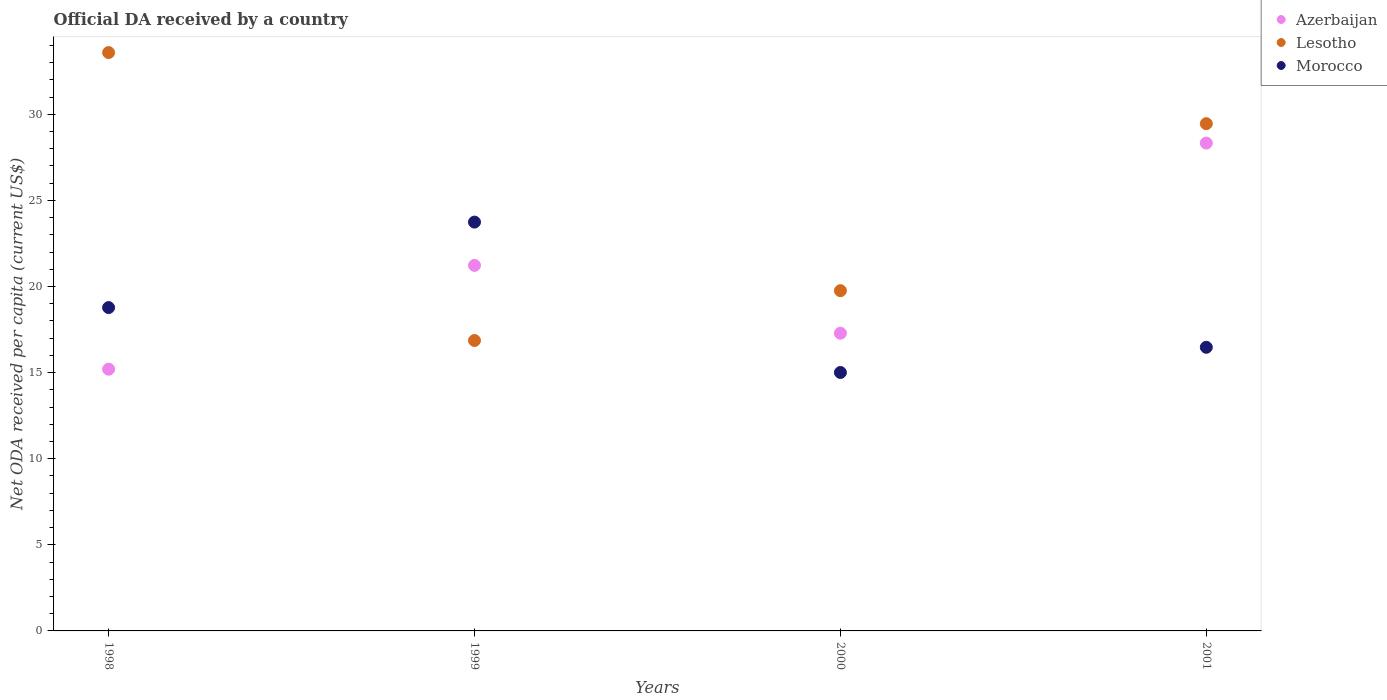How many different coloured dotlines are there?
Your answer should be very brief. 3. What is the ODA received in in Azerbaijan in 1999?
Provide a short and direct response. 21.22. Across all years, what is the maximum ODA received in in Morocco?
Give a very brief answer. 23.74. Across all years, what is the minimum ODA received in in Lesotho?
Make the answer very short. 16.86. In which year was the ODA received in in Azerbaijan maximum?
Offer a very short reply. 2001. What is the total ODA received in in Morocco in the graph?
Provide a succinct answer. 73.98. What is the difference between the ODA received in in Lesotho in 1999 and that in 2000?
Your answer should be compact. -2.89. What is the difference between the ODA received in in Azerbaijan in 1999 and the ODA received in in Lesotho in 2000?
Your answer should be very brief. 1.47. What is the average ODA received in in Azerbaijan per year?
Offer a very short reply. 20.51. In the year 1999, what is the difference between the ODA received in in Azerbaijan and ODA received in in Morocco?
Provide a succinct answer. -2.51. In how many years, is the ODA received in in Lesotho greater than 1 US$?
Ensure brevity in your answer.  4. What is the ratio of the ODA received in in Azerbaijan in 1999 to that in 2001?
Your answer should be compact. 0.75. Is the ODA received in in Morocco in 1998 less than that in 2001?
Offer a terse response. No. What is the difference between the highest and the second highest ODA received in in Morocco?
Your answer should be very brief. 4.96. What is the difference between the highest and the lowest ODA received in in Lesotho?
Make the answer very short. 16.72. In how many years, is the ODA received in in Morocco greater than the average ODA received in in Morocco taken over all years?
Offer a very short reply. 2. Is the ODA received in in Azerbaijan strictly greater than the ODA received in in Morocco over the years?
Ensure brevity in your answer.  No. How many dotlines are there?
Make the answer very short. 3. Does the graph contain any zero values?
Offer a terse response. No. What is the title of the graph?
Ensure brevity in your answer.  Official DA received by a country. What is the label or title of the X-axis?
Offer a very short reply. Years. What is the label or title of the Y-axis?
Offer a terse response. Net ODA received per capita (current US$). What is the Net ODA received per capita (current US$) of Azerbaijan in 1998?
Make the answer very short. 15.2. What is the Net ODA received per capita (current US$) in Lesotho in 1998?
Provide a succinct answer. 33.58. What is the Net ODA received per capita (current US$) of Morocco in 1998?
Your answer should be very brief. 18.77. What is the Net ODA received per capita (current US$) of Azerbaijan in 1999?
Keep it short and to the point. 21.22. What is the Net ODA received per capita (current US$) in Lesotho in 1999?
Ensure brevity in your answer.  16.86. What is the Net ODA received per capita (current US$) in Morocco in 1999?
Ensure brevity in your answer.  23.74. What is the Net ODA received per capita (current US$) of Azerbaijan in 2000?
Provide a succinct answer. 17.28. What is the Net ODA received per capita (current US$) in Lesotho in 2000?
Give a very brief answer. 19.76. What is the Net ODA received per capita (current US$) in Morocco in 2000?
Provide a short and direct response. 15.01. What is the Net ODA received per capita (current US$) of Azerbaijan in 2001?
Give a very brief answer. 28.33. What is the Net ODA received per capita (current US$) in Lesotho in 2001?
Offer a terse response. 29.45. What is the Net ODA received per capita (current US$) in Morocco in 2001?
Your answer should be very brief. 16.47. Across all years, what is the maximum Net ODA received per capita (current US$) of Azerbaijan?
Offer a very short reply. 28.33. Across all years, what is the maximum Net ODA received per capita (current US$) of Lesotho?
Your response must be concise. 33.58. Across all years, what is the maximum Net ODA received per capita (current US$) in Morocco?
Your answer should be compact. 23.74. Across all years, what is the minimum Net ODA received per capita (current US$) of Azerbaijan?
Make the answer very short. 15.2. Across all years, what is the minimum Net ODA received per capita (current US$) in Lesotho?
Provide a succinct answer. 16.86. Across all years, what is the minimum Net ODA received per capita (current US$) of Morocco?
Ensure brevity in your answer.  15.01. What is the total Net ODA received per capita (current US$) of Azerbaijan in the graph?
Offer a very short reply. 82.03. What is the total Net ODA received per capita (current US$) of Lesotho in the graph?
Give a very brief answer. 99.65. What is the total Net ODA received per capita (current US$) in Morocco in the graph?
Make the answer very short. 73.98. What is the difference between the Net ODA received per capita (current US$) of Azerbaijan in 1998 and that in 1999?
Keep it short and to the point. -6.03. What is the difference between the Net ODA received per capita (current US$) in Lesotho in 1998 and that in 1999?
Make the answer very short. 16.72. What is the difference between the Net ODA received per capita (current US$) of Morocco in 1998 and that in 1999?
Make the answer very short. -4.96. What is the difference between the Net ODA received per capita (current US$) of Azerbaijan in 1998 and that in 2000?
Ensure brevity in your answer.  -2.09. What is the difference between the Net ODA received per capita (current US$) of Lesotho in 1998 and that in 2000?
Make the answer very short. 13.82. What is the difference between the Net ODA received per capita (current US$) in Morocco in 1998 and that in 2000?
Your answer should be very brief. 3.77. What is the difference between the Net ODA received per capita (current US$) in Azerbaijan in 1998 and that in 2001?
Keep it short and to the point. -13.13. What is the difference between the Net ODA received per capita (current US$) in Lesotho in 1998 and that in 2001?
Your response must be concise. 4.13. What is the difference between the Net ODA received per capita (current US$) in Morocco in 1998 and that in 2001?
Ensure brevity in your answer.  2.31. What is the difference between the Net ODA received per capita (current US$) in Azerbaijan in 1999 and that in 2000?
Give a very brief answer. 3.94. What is the difference between the Net ODA received per capita (current US$) in Lesotho in 1999 and that in 2000?
Your answer should be very brief. -2.89. What is the difference between the Net ODA received per capita (current US$) of Morocco in 1999 and that in 2000?
Offer a terse response. 8.73. What is the difference between the Net ODA received per capita (current US$) in Azerbaijan in 1999 and that in 2001?
Provide a short and direct response. -7.1. What is the difference between the Net ODA received per capita (current US$) of Lesotho in 1999 and that in 2001?
Make the answer very short. -12.59. What is the difference between the Net ODA received per capita (current US$) of Morocco in 1999 and that in 2001?
Your answer should be very brief. 7.27. What is the difference between the Net ODA received per capita (current US$) in Azerbaijan in 2000 and that in 2001?
Your answer should be very brief. -11.04. What is the difference between the Net ODA received per capita (current US$) in Lesotho in 2000 and that in 2001?
Your answer should be compact. -9.7. What is the difference between the Net ODA received per capita (current US$) of Morocco in 2000 and that in 2001?
Make the answer very short. -1.46. What is the difference between the Net ODA received per capita (current US$) of Azerbaijan in 1998 and the Net ODA received per capita (current US$) of Lesotho in 1999?
Make the answer very short. -1.67. What is the difference between the Net ODA received per capita (current US$) in Azerbaijan in 1998 and the Net ODA received per capita (current US$) in Morocco in 1999?
Ensure brevity in your answer.  -8.54. What is the difference between the Net ODA received per capita (current US$) of Lesotho in 1998 and the Net ODA received per capita (current US$) of Morocco in 1999?
Offer a terse response. 9.84. What is the difference between the Net ODA received per capita (current US$) in Azerbaijan in 1998 and the Net ODA received per capita (current US$) in Lesotho in 2000?
Keep it short and to the point. -4.56. What is the difference between the Net ODA received per capita (current US$) in Azerbaijan in 1998 and the Net ODA received per capita (current US$) in Morocco in 2000?
Provide a short and direct response. 0.19. What is the difference between the Net ODA received per capita (current US$) in Lesotho in 1998 and the Net ODA received per capita (current US$) in Morocco in 2000?
Your answer should be very brief. 18.57. What is the difference between the Net ODA received per capita (current US$) in Azerbaijan in 1998 and the Net ODA received per capita (current US$) in Lesotho in 2001?
Make the answer very short. -14.26. What is the difference between the Net ODA received per capita (current US$) of Azerbaijan in 1998 and the Net ODA received per capita (current US$) of Morocco in 2001?
Offer a terse response. -1.27. What is the difference between the Net ODA received per capita (current US$) in Lesotho in 1998 and the Net ODA received per capita (current US$) in Morocco in 2001?
Provide a short and direct response. 17.11. What is the difference between the Net ODA received per capita (current US$) in Azerbaijan in 1999 and the Net ODA received per capita (current US$) in Lesotho in 2000?
Your answer should be very brief. 1.47. What is the difference between the Net ODA received per capita (current US$) in Azerbaijan in 1999 and the Net ODA received per capita (current US$) in Morocco in 2000?
Give a very brief answer. 6.22. What is the difference between the Net ODA received per capita (current US$) of Lesotho in 1999 and the Net ODA received per capita (current US$) of Morocco in 2000?
Offer a terse response. 1.86. What is the difference between the Net ODA received per capita (current US$) of Azerbaijan in 1999 and the Net ODA received per capita (current US$) of Lesotho in 2001?
Provide a succinct answer. -8.23. What is the difference between the Net ODA received per capita (current US$) of Azerbaijan in 1999 and the Net ODA received per capita (current US$) of Morocco in 2001?
Your answer should be very brief. 4.76. What is the difference between the Net ODA received per capita (current US$) of Lesotho in 1999 and the Net ODA received per capita (current US$) of Morocco in 2001?
Offer a very short reply. 0.39. What is the difference between the Net ODA received per capita (current US$) of Azerbaijan in 2000 and the Net ODA received per capita (current US$) of Lesotho in 2001?
Your response must be concise. -12.17. What is the difference between the Net ODA received per capita (current US$) of Azerbaijan in 2000 and the Net ODA received per capita (current US$) of Morocco in 2001?
Your answer should be very brief. 0.82. What is the difference between the Net ODA received per capita (current US$) in Lesotho in 2000 and the Net ODA received per capita (current US$) in Morocco in 2001?
Provide a succinct answer. 3.29. What is the average Net ODA received per capita (current US$) of Azerbaijan per year?
Offer a terse response. 20.51. What is the average Net ODA received per capita (current US$) in Lesotho per year?
Provide a short and direct response. 24.91. What is the average Net ODA received per capita (current US$) of Morocco per year?
Keep it short and to the point. 18.5. In the year 1998, what is the difference between the Net ODA received per capita (current US$) of Azerbaijan and Net ODA received per capita (current US$) of Lesotho?
Provide a succinct answer. -18.38. In the year 1998, what is the difference between the Net ODA received per capita (current US$) of Azerbaijan and Net ODA received per capita (current US$) of Morocco?
Make the answer very short. -3.58. In the year 1998, what is the difference between the Net ODA received per capita (current US$) in Lesotho and Net ODA received per capita (current US$) in Morocco?
Your answer should be compact. 14.81. In the year 1999, what is the difference between the Net ODA received per capita (current US$) in Azerbaijan and Net ODA received per capita (current US$) in Lesotho?
Provide a succinct answer. 4.36. In the year 1999, what is the difference between the Net ODA received per capita (current US$) in Azerbaijan and Net ODA received per capita (current US$) in Morocco?
Your response must be concise. -2.51. In the year 1999, what is the difference between the Net ODA received per capita (current US$) of Lesotho and Net ODA received per capita (current US$) of Morocco?
Offer a terse response. -6.87. In the year 2000, what is the difference between the Net ODA received per capita (current US$) of Azerbaijan and Net ODA received per capita (current US$) of Lesotho?
Your answer should be very brief. -2.47. In the year 2000, what is the difference between the Net ODA received per capita (current US$) of Azerbaijan and Net ODA received per capita (current US$) of Morocco?
Provide a succinct answer. 2.28. In the year 2000, what is the difference between the Net ODA received per capita (current US$) in Lesotho and Net ODA received per capita (current US$) in Morocco?
Keep it short and to the point. 4.75. In the year 2001, what is the difference between the Net ODA received per capita (current US$) of Azerbaijan and Net ODA received per capita (current US$) of Lesotho?
Make the answer very short. -1.13. In the year 2001, what is the difference between the Net ODA received per capita (current US$) of Azerbaijan and Net ODA received per capita (current US$) of Morocco?
Provide a short and direct response. 11.86. In the year 2001, what is the difference between the Net ODA received per capita (current US$) of Lesotho and Net ODA received per capita (current US$) of Morocco?
Offer a terse response. 12.98. What is the ratio of the Net ODA received per capita (current US$) in Azerbaijan in 1998 to that in 1999?
Provide a succinct answer. 0.72. What is the ratio of the Net ODA received per capita (current US$) of Lesotho in 1998 to that in 1999?
Ensure brevity in your answer.  1.99. What is the ratio of the Net ODA received per capita (current US$) in Morocco in 1998 to that in 1999?
Your response must be concise. 0.79. What is the ratio of the Net ODA received per capita (current US$) in Azerbaijan in 1998 to that in 2000?
Your answer should be compact. 0.88. What is the ratio of the Net ODA received per capita (current US$) of Lesotho in 1998 to that in 2000?
Give a very brief answer. 1.7. What is the ratio of the Net ODA received per capita (current US$) of Morocco in 1998 to that in 2000?
Your response must be concise. 1.25. What is the ratio of the Net ODA received per capita (current US$) of Azerbaijan in 1998 to that in 2001?
Provide a succinct answer. 0.54. What is the ratio of the Net ODA received per capita (current US$) of Lesotho in 1998 to that in 2001?
Provide a short and direct response. 1.14. What is the ratio of the Net ODA received per capita (current US$) of Morocco in 1998 to that in 2001?
Your response must be concise. 1.14. What is the ratio of the Net ODA received per capita (current US$) of Azerbaijan in 1999 to that in 2000?
Make the answer very short. 1.23. What is the ratio of the Net ODA received per capita (current US$) of Lesotho in 1999 to that in 2000?
Make the answer very short. 0.85. What is the ratio of the Net ODA received per capita (current US$) of Morocco in 1999 to that in 2000?
Offer a very short reply. 1.58. What is the ratio of the Net ODA received per capita (current US$) of Azerbaijan in 1999 to that in 2001?
Ensure brevity in your answer.  0.75. What is the ratio of the Net ODA received per capita (current US$) of Lesotho in 1999 to that in 2001?
Your response must be concise. 0.57. What is the ratio of the Net ODA received per capita (current US$) of Morocco in 1999 to that in 2001?
Your answer should be very brief. 1.44. What is the ratio of the Net ODA received per capita (current US$) in Azerbaijan in 2000 to that in 2001?
Keep it short and to the point. 0.61. What is the ratio of the Net ODA received per capita (current US$) of Lesotho in 2000 to that in 2001?
Provide a short and direct response. 0.67. What is the ratio of the Net ODA received per capita (current US$) of Morocco in 2000 to that in 2001?
Your answer should be compact. 0.91. What is the difference between the highest and the second highest Net ODA received per capita (current US$) of Azerbaijan?
Provide a succinct answer. 7.1. What is the difference between the highest and the second highest Net ODA received per capita (current US$) of Lesotho?
Provide a succinct answer. 4.13. What is the difference between the highest and the second highest Net ODA received per capita (current US$) of Morocco?
Ensure brevity in your answer.  4.96. What is the difference between the highest and the lowest Net ODA received per capita (current US$) in Azerbaijan?
Your response must be concise. 13.13. What is the difference between the highest and the lowest Net ODA received per capita (current US$) of Lesotho?
Ensure brevity in your answer.  16.72. What is the difference between the highest and the lowest Net ODA received per capita (current US$) of Morocco?
Keep it short and to the point. 8.73. 